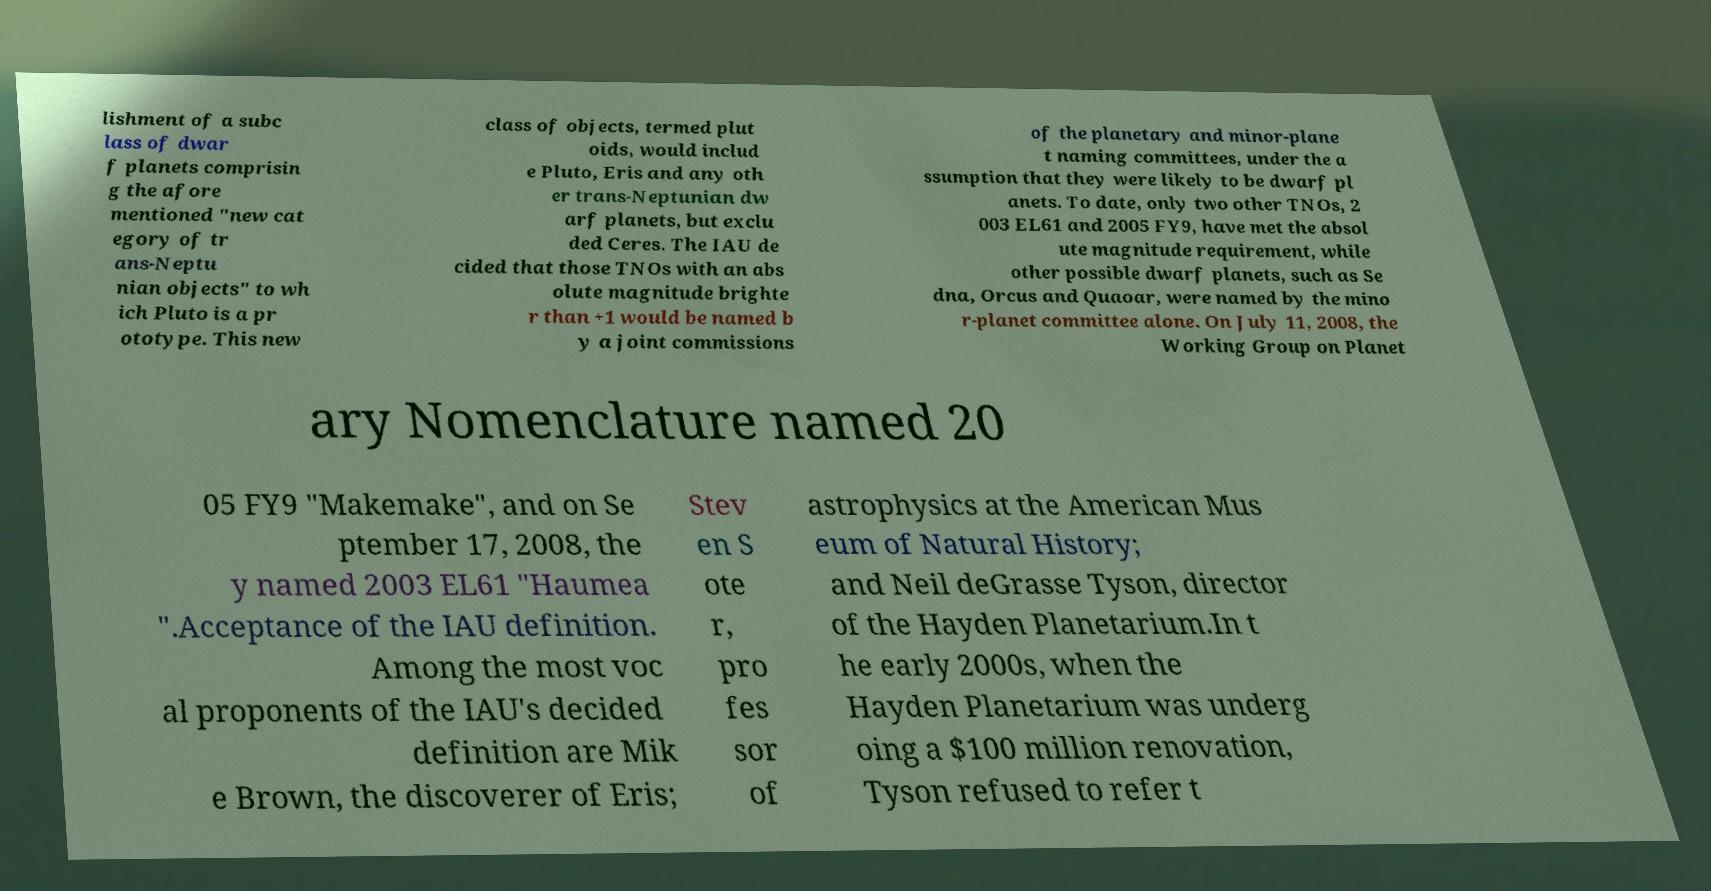Please identify and transcribe the text found in this image. lishment of a subc lass of dwar f planets comprisin g the afore mentioned "new cat egory of tr ans-Neptu nian objects" to wh ich Pluto is a pr ototype. This new class of objects, termed plut oids, would includ e Pluto, Eris and any oth er trans-Neptunian dw arf planets, but exclu ded Ceres. The IAU de cided that those TNOs with an abs olute magnitude brighte r than +1 would be named b y a joint commissions of the planetary and minor-plane t naming committees, under the a ssumption that they were likely to be dwarf pl anets. To date, only two other TNOs, 2 003 EL61 and 2005 FY9, have met the absol ute magnitude requirement, while other possible dwarf planets, such as Se dna, Orcus and Quaoar, were named by the mino r-planet committee alone. On July 11, 2008, the Working Group on Planet ary Nomenclature named 20 05 FY9 "Makemake", and on Se ptember 17, 2008, the y named 2003 EL61 "Haumea ".Acceptance of the IAU definition. Among the most voc al proponents of the IAU's decided definition are Mik e Brown, the discoverer of Eris; Stev en S ote r, pro fes sor of astrophysics at the American Mus eum of Natural History; and Neil deGrasse Tyson, director of the Hayden Planetarium.In t he early 2000s, when the Hayden Planetarium was underg oing a $100 million renovation, Tyson refused to refer t 